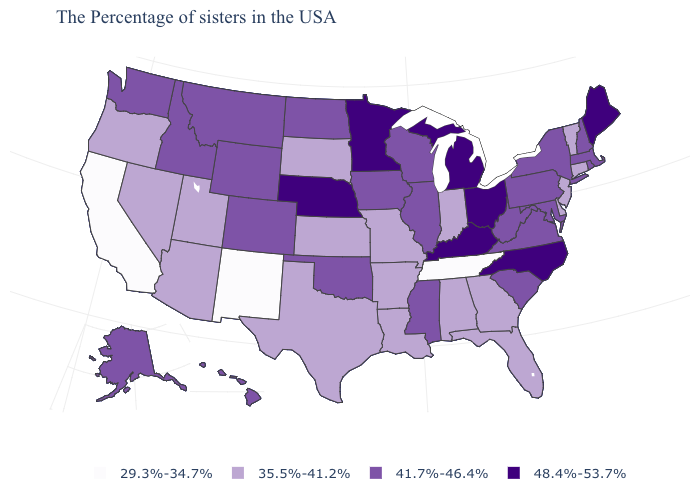What is the value of Vermont?
Quick response, please. 35.5%-41.2%. Name the states that have a value in the range 35.5%-41.2%?
Write a very short answer. Vermont, Connecticut, New Jersey, Delaware, Florida, Georgia, Indiana, Alabama, Louisiana, Missouri, Arkansas, Kansas, Texas, South Dakota, Utah, Arizona, Nevada, Oregon. Name the states that have a value in the range 35.5%-41.2%?
Keep it brief. Vermont, Connecticut, New Jersey, Delaware, Florida, Georgia, Indiana, Alabama, Louisiana, Missouri, Arkansas, Kansas, Texas, South Dakota, Utah, Arizona, Nevada, Oregon. Does Mississippi have a lower value than Michigan?
Answer briefly. Yes. Does the map have missing data?
Be succinct. No. Name the states that have a value in the range 35.5%-41.2%?
Give a very brief answer. Vermont, Connecticut, New Jersey, Delaware, Florida, Georgia, Indiana, Alabama, Louisiana, Missouri, Arkansas, Kansas, Texas, South Dakota, Utah, Arizona, Nevada, Oregon. What is the value of New York?
Be succinct. 41.7%-46.4%. Name the states that have a value in the range 29.3%-34.7%?
Write a very short answer. Tennessee, New Mexico, California. Does the first symbol in the legend represent the smallest category?
Write a very short answer. Yes. Which states hav the highest value in the South?
Concise answer only. North Carolina, Kentucky. Name the states that have a value in the range 29.3%-34.7%?
Write a very short answer. Tennessee, New Mexico, California. Does the first symbol in the legend represent the smallest category?
Keep it brief. Yes. How many symbols are there in the legend?
Answer briefly. 4. Name the states that have a value in the range 29.3%-34.7%?
Be succinct. Tennessee, New Mexico, California. 